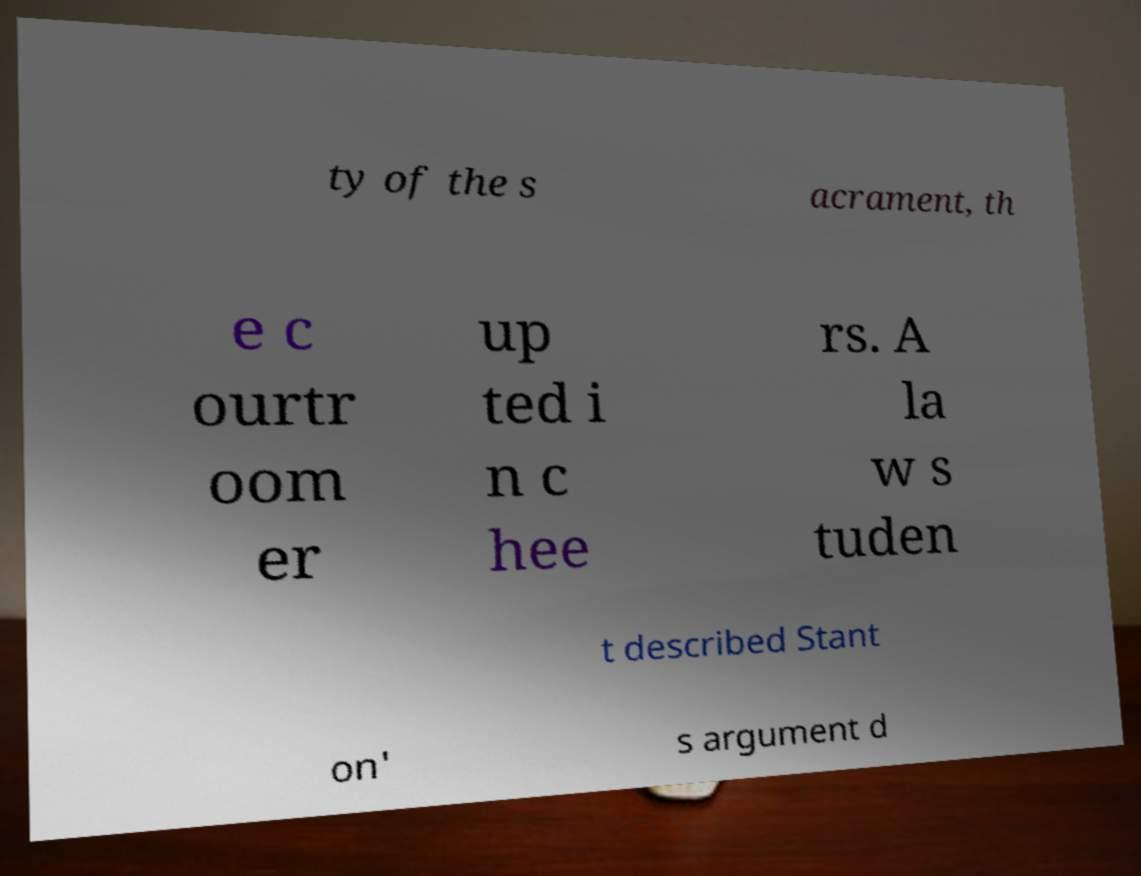Please identify and transcribe the text found in this image. ty of the s acrament, th e c ourtr oom er up ted i n c hee rs. A la w s tuden t described Stant on' s argument d 